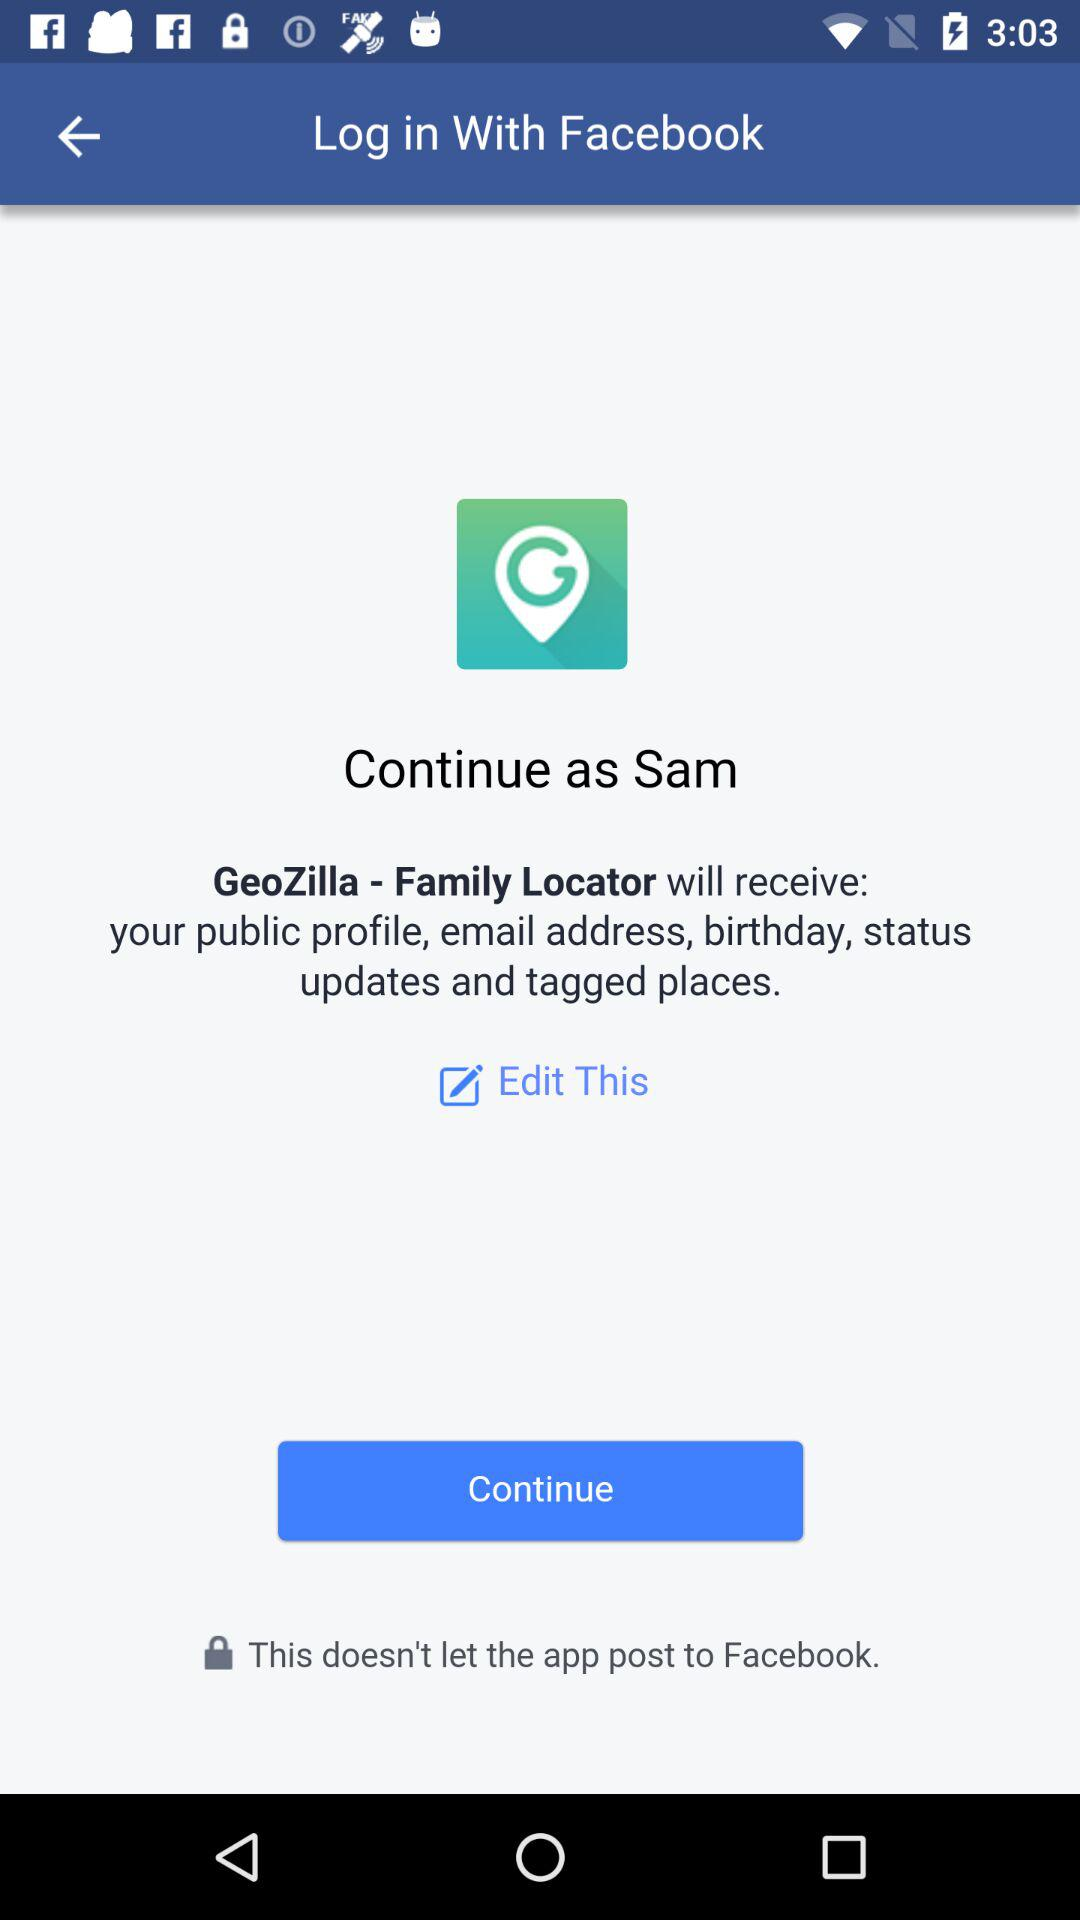Through what application can we log in? You can log in with "Facebook". 